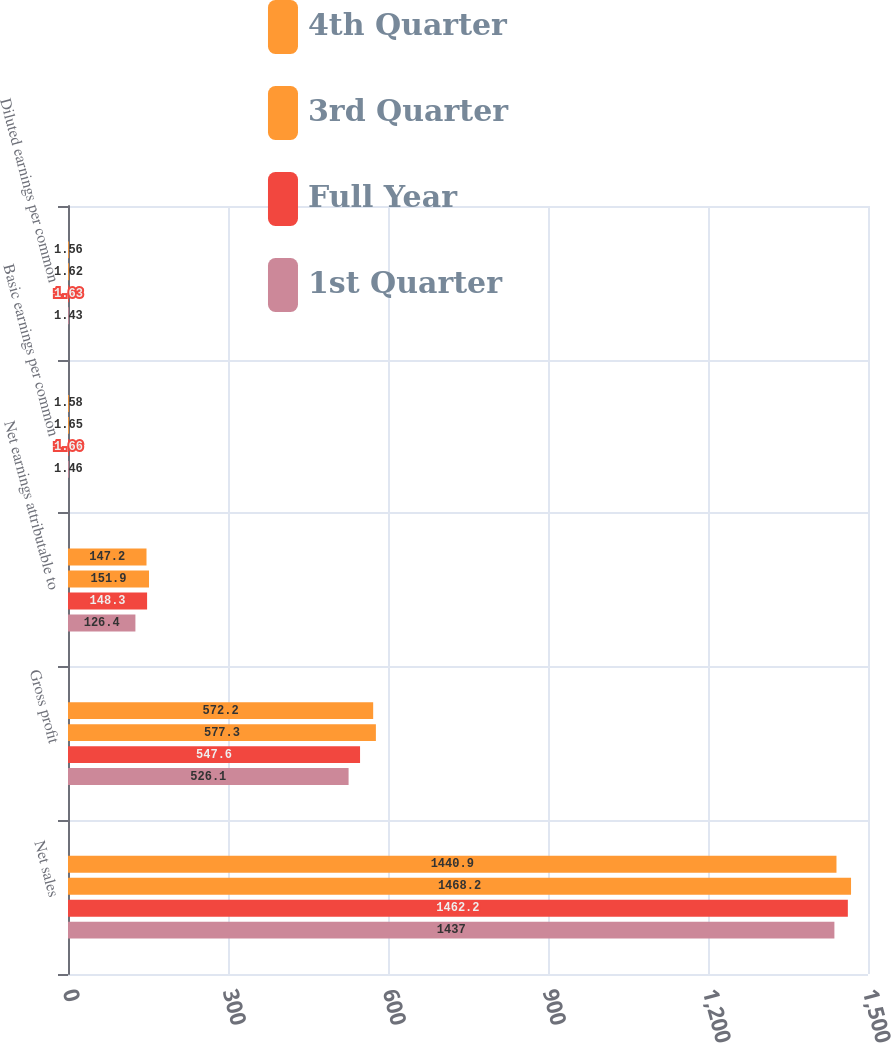Convert chart to OTSL. <chart><loc_0><loc_0><loc_500><loc_500><stacked_bar_chart><ecel><fcel>Net sales<fcel>Gross profit<fcel>Net earnings attributable to<fcel>Basic earnings per common<fcel>Diluted earnings per common<nl><fcel>4th Quarter<fcel>1440.9<fcel>572.2<fcel>147.2<fcel>1.58<fcel>1.56<nl><fcel>3rd Quarter<fcel>1468.2<fcel>577.3<fcel>151.9<fcel>1.65<fcel>1.62<nl><fcel>Full Year<fcel>1462.2<fcel>547.6<fcel>148.3<fcel>1.66<fcel>1.63<nl><fcel>1st Quarter<fcel>1437<fcel>526.1<fcel>126.4<fcel>1.46<fcel>1.43<nl></chart> 